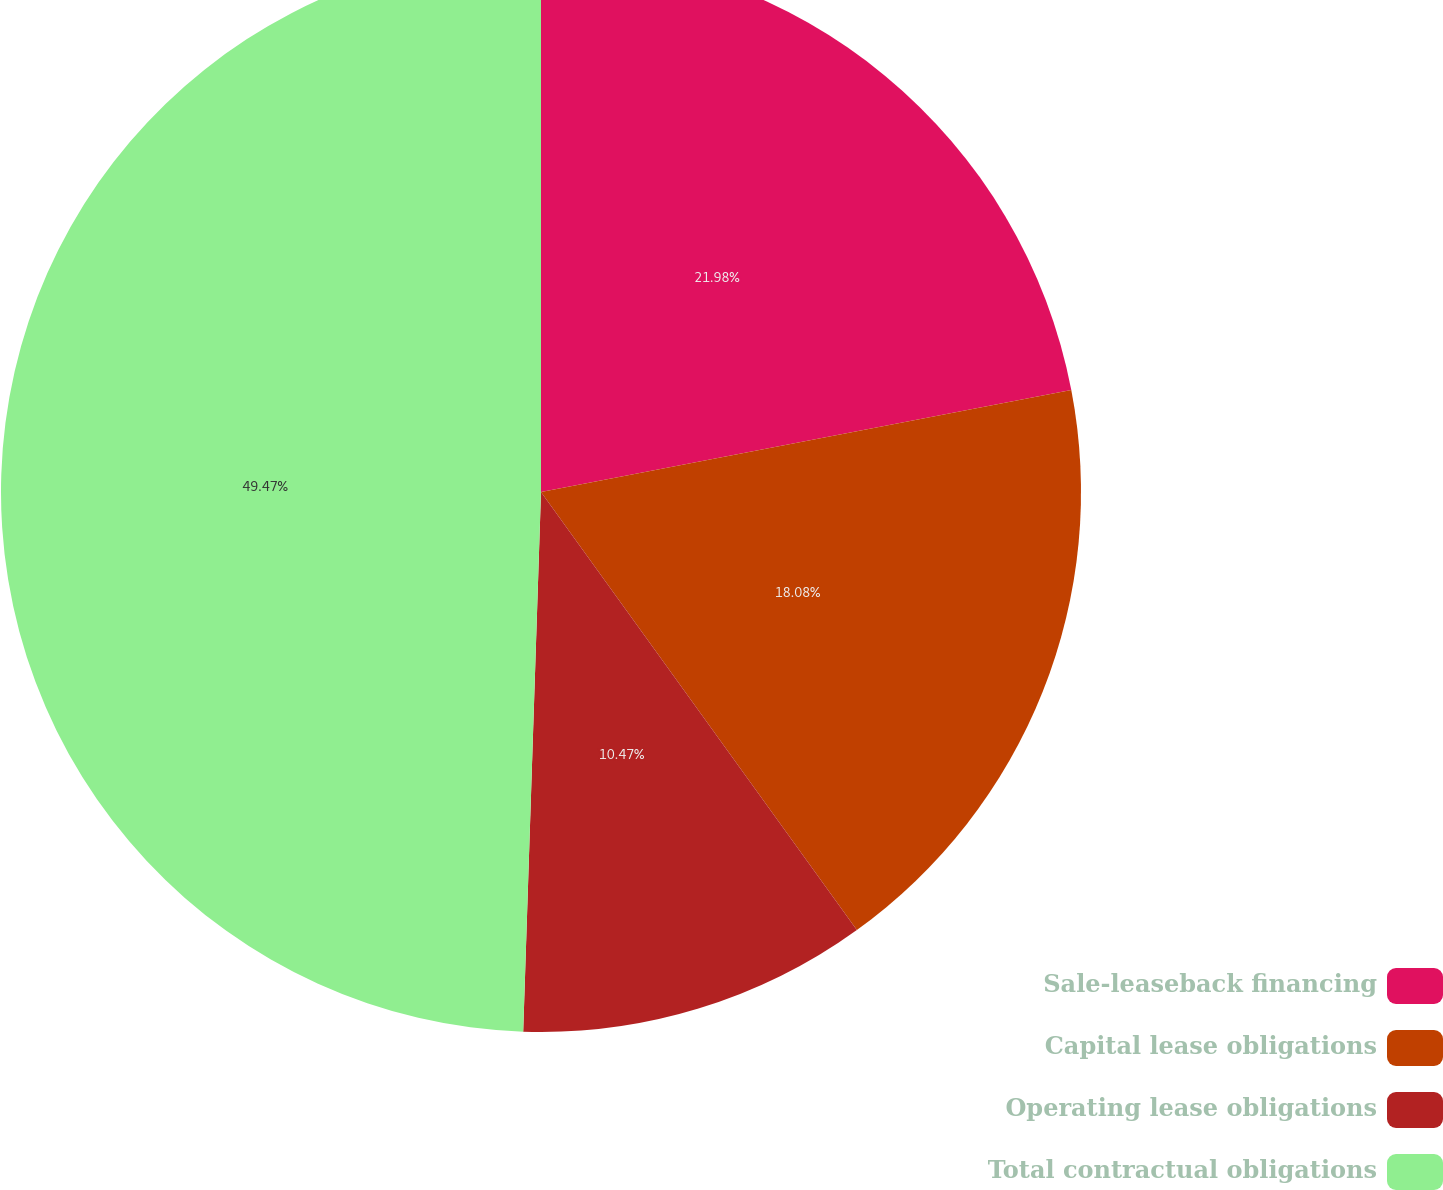Convert chart to OTSL. <chart><loc_0><loc_0><loc_500><loc_500><pie_chart><fcel>Sale-leaseback financing<fcel>Capital lease obligations<fcel>Operating lease obligations<fcel>Total contractual obligations<nl><fcel>21.98%<fcel>18.08%<fcel>10.47%<fcel>49.48%<nl></chart> 